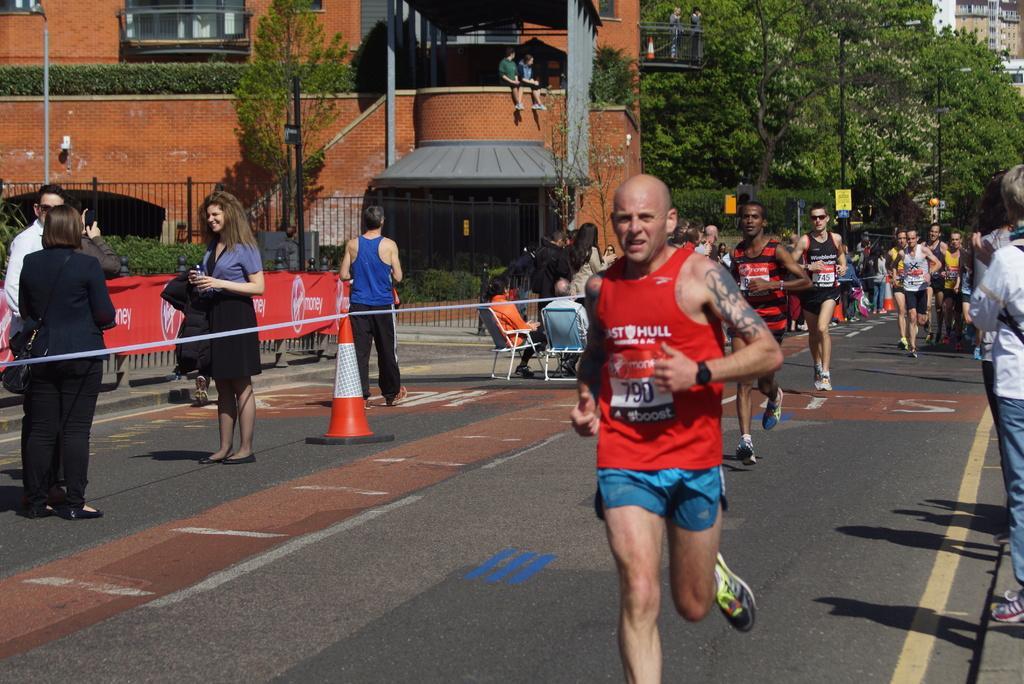Could you give a brief overview of what you see in this image? On the right side of the image we can see people running. On the left there are people standing and some of them are sitting. In the background we can see buildings, trees and fence. 